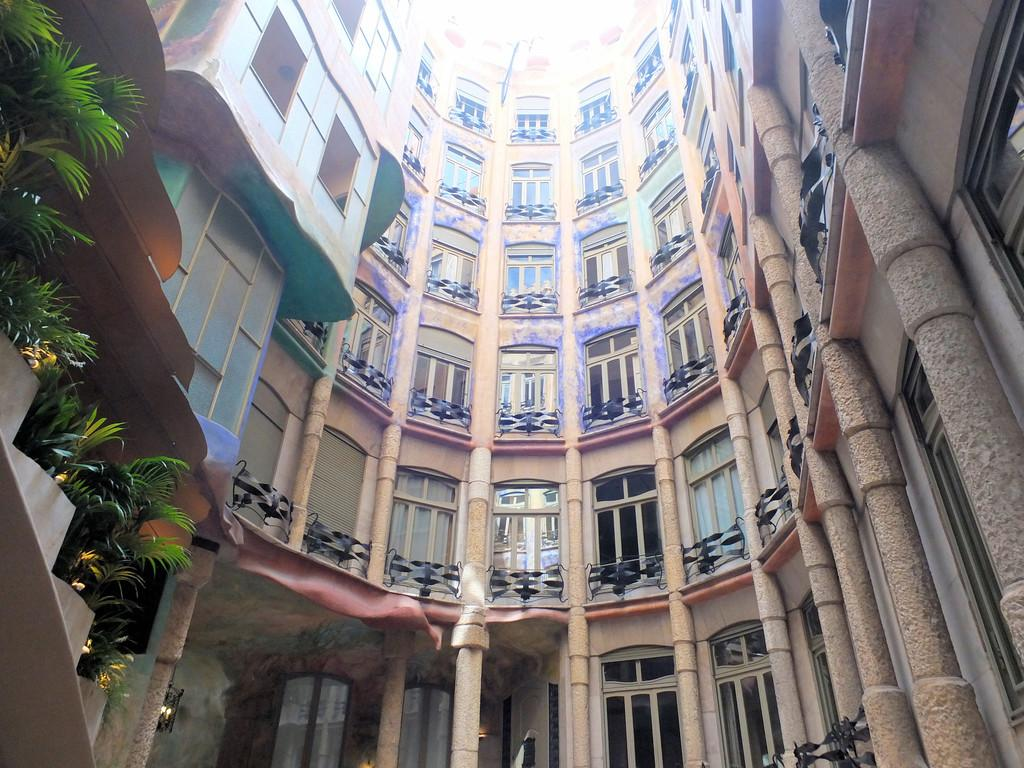What type of structure is visible in the image? There is a building in the image. What can be seen on the left side of the image? There are plants on the left side of the image. Where are the pillars located in the image? The pillars are in the bottom right of the image. How many frogs are sitting on the roof of the building in the image? There are no frogs present in the image, so it is not possible to determine how many might be sitting on the roof. 